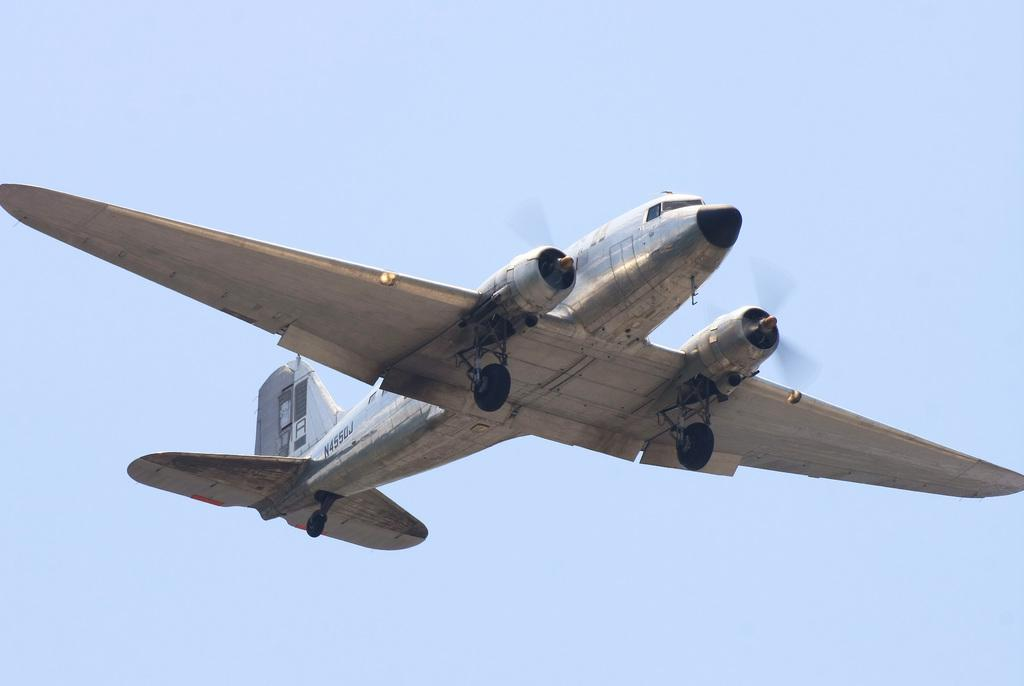What type of object is visible in the image? There is a silver-colored craft in the image. What is the craft doing in the image? The craft is flying in the sky. What color is the sky in the image? The sky is blue in the image. Are there any dinosaurs visible in the image? No, there are no dinosaurs present in the image. Is the queen mentioned or depicted in the image? No, the queen is not mentioned or depicted in the image. 